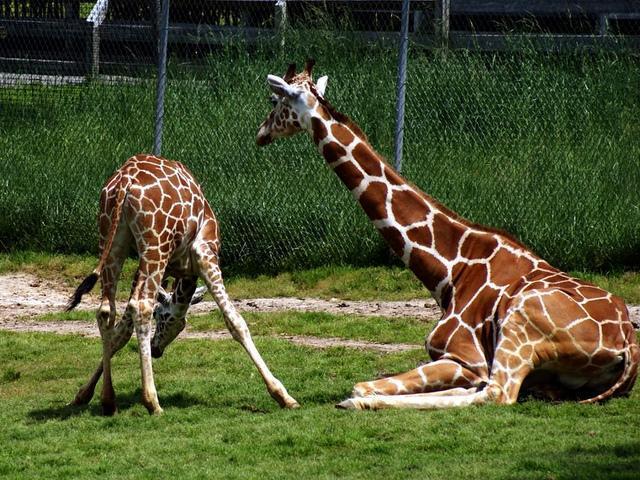How many giraffes can be seen?
Give a very brief answer. 2. 